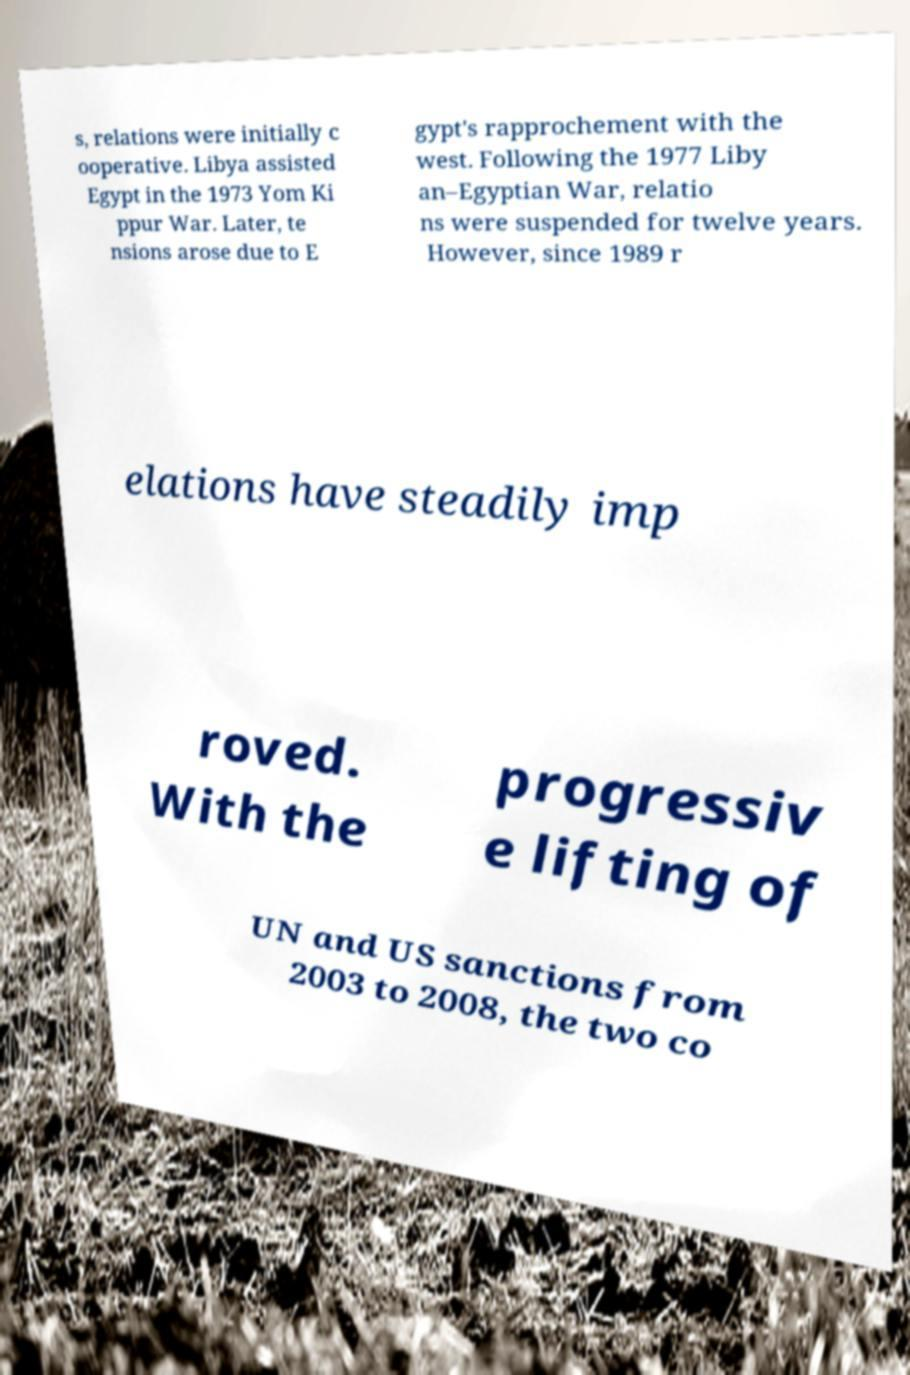There's text embedded in this image that I need extracted. Can you transcribe it verbatim? s, relations were initially c ooperative. Libya assisted Egypt in the 1973 Yom Ki ppur War. Later, te nsions arose due to E gypt's rapprochement with the west. Following the 1977 Liby an–Egyptian War, relatio ns were suspended for twelve years. However, since 1989 r elations have steadily imp roved. With the progressiv e lifting of UN and US sanctions from 2003 to 2008, the two co 